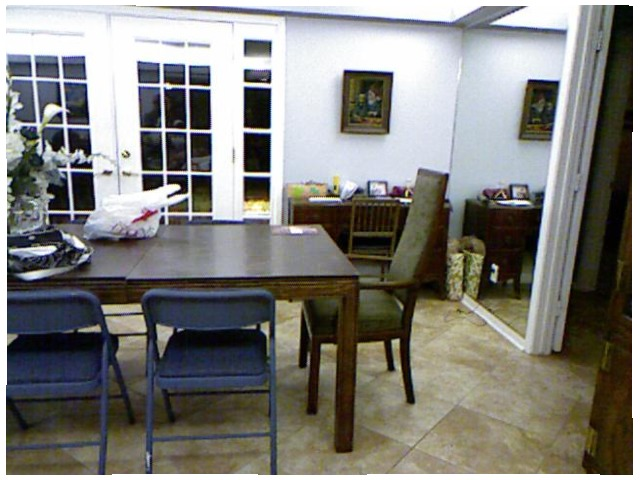<image>
Is the picture on the wall? No. The picture is not positioned on the wall. They may be near each other, but the picture is not supported by or resting on top of the wall. Is there a chair on the table? No. The chair is not positioned on the table. They may be near each other, but the chair is not supported by or resting on top of the table. Is there a door to the right of the table? Yes. From this viewpoint, the door is positioned to the right side relative to the table. Is the chair to the right of the table? Yes. From this viewpoint, the chair is positioned to the right side relative to the table. Is there a chair to the left of the mirror? Yes. From this viewpoint, the chair is positioned to the left side relative to the mirror. Is there a chair next to the table? No. The chair is not positioned next to the table. They are located in different areas of the scene. 